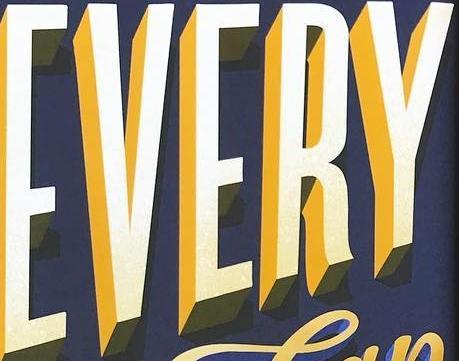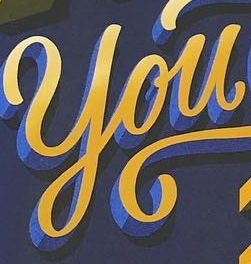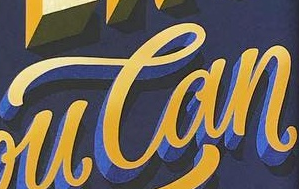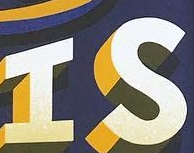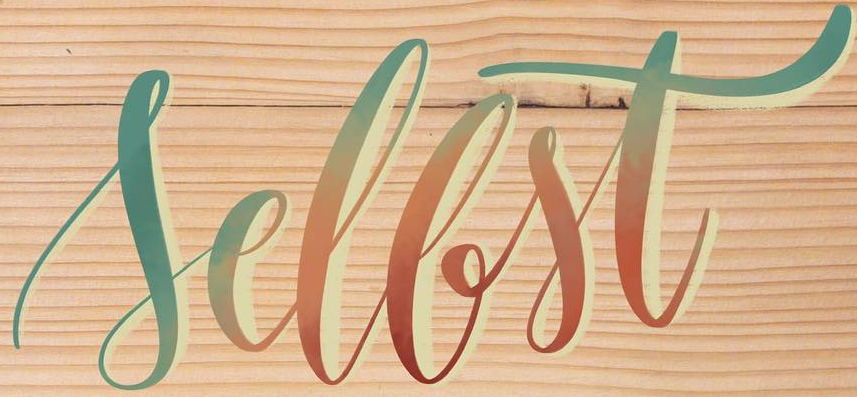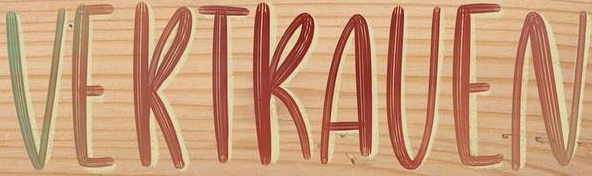What text appears in these images from left to right, separated by a semicolon? EVERY; You; Can; IS; Sellst; VERTRAVEN 